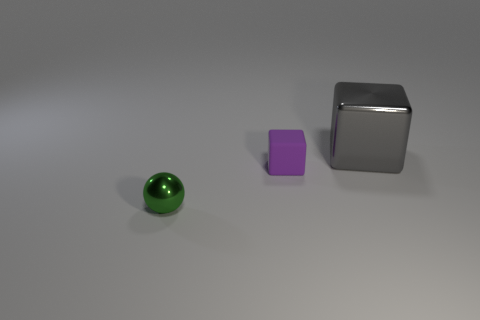Is there any other thing that is made of the same material as the small purple thing?
Provide a short and direct response. No. Do the tiny sphere and the tiny thing that is on the right side of the tiny green metallic thing have the same material?
Offer a terse response. No. Is there another green thing that has the same shape as the large shiny thing?
Ensure brevity in your answer.  No. What is the material of the sphere that is the same size as the purple matte object?
Your answer should be very brief. Metal. There is a metallic object on the right side of the tiny green metal thing; how big is it?
Offer a terse response. Large. There is a metal object in front of the gray cube; is its size the same as the shiny thing behind the green ball?
Your answer should be compact. No. What number of tiny green spheres are made of the same material as the large gray thing?
Your answer should be compact. 1. The small matte thing is what color?
Your answer should be compact. Purple. Are there any things behind the tiny metal ball?
Your answer should be very brief. Yes. What is the size of the metallic object behind the thing that is on the left side of the tiny purple rubber thing?
Provide a succinct answer. Large. 